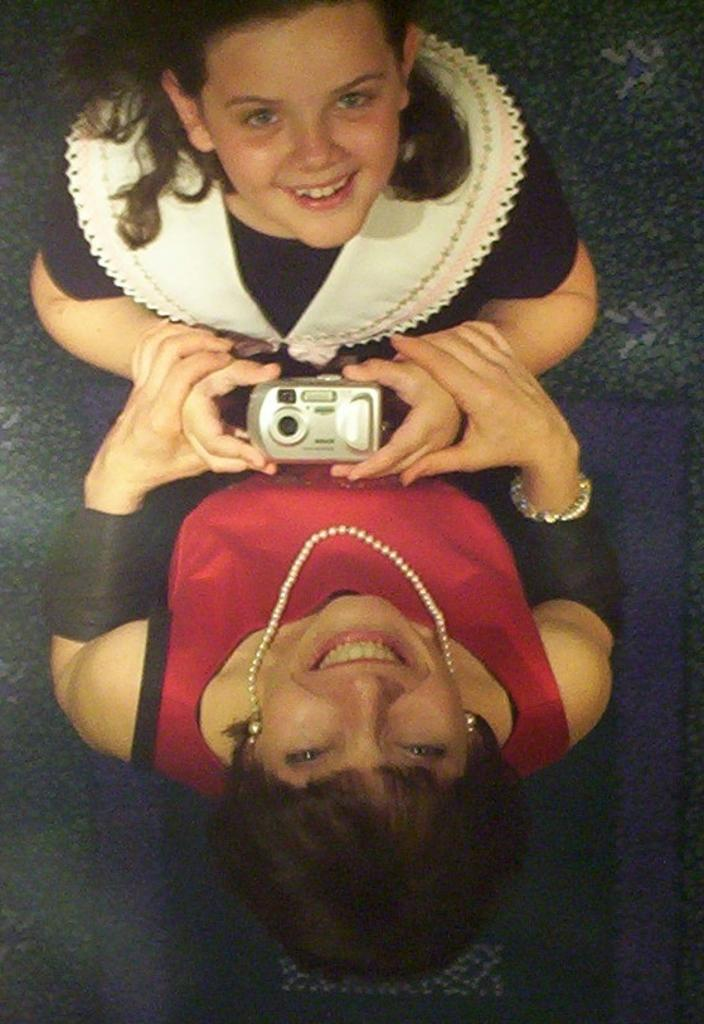What is happening in the image? There are women standing in the image, and they are smiling. Can you describe the clothing of one of the women? Yes, there is a woman wearing a black color dress. What is the expression of the woman in the black dress? The woman in the black dress is smiling. What is the woman in the black dress holding? The woman in the black dress is holding a camera. What type of committee is being formed in the image? There is no mention of a committee being formed in the image; it features women standing and smiling. What kind of mine is visible in the image? There is no mine present in the image. 